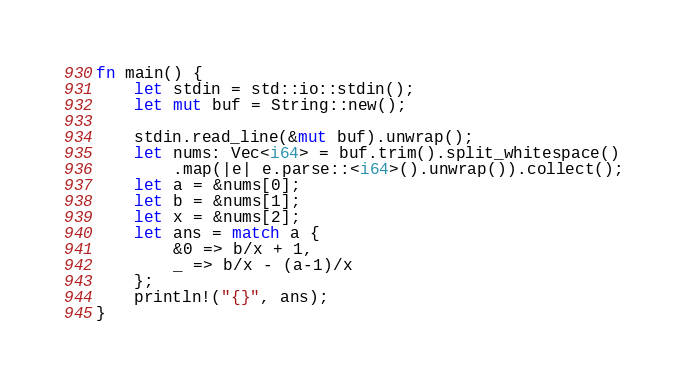Convert code to text. <code><loc_0><loc_0><loc_500><loc_500><_Rust_>fn main() {
    let stdin = std::io::stdin();
    let mut buf = String::new();

    stdin.read_line(&mut buf).unwrap();
    let nums: Vec<i64> = buf.trim().split_whitespace()
        .map(|e| e.parse::<i64>().unwrap()).collect();
    let a = &nums[0];
    let b = &nums[1];
    let x = &nums[2];
    let ans = match a {
        &0 => b/x + 1,
        _ => b/x - (a-1)/x
    };
    println!("{}", ans);
}
</code> 